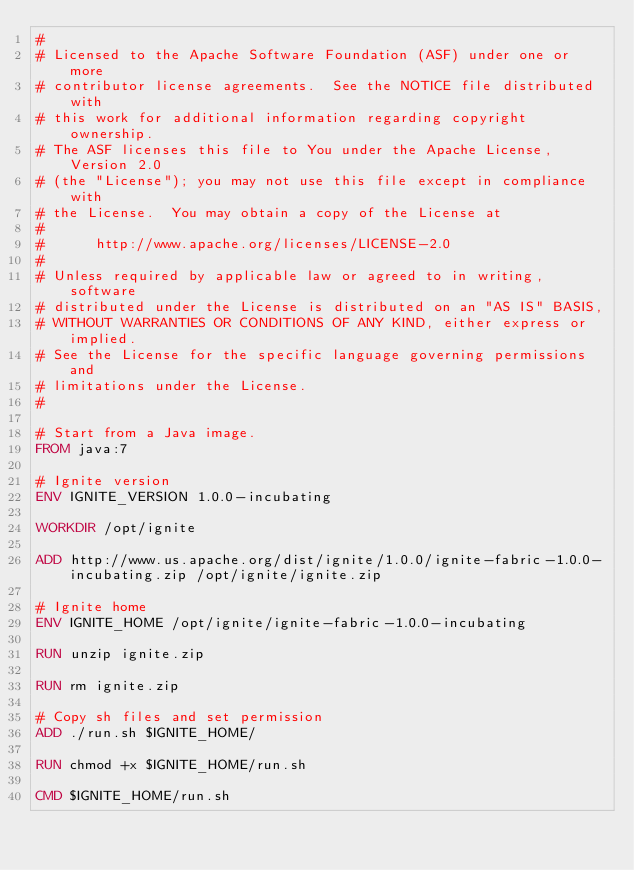<code> <loc_0><loc_0><loc_500><loc_500><_Dockerfile_>#
# Licensed to the Apache Software Foundation (ASF) under one or more
# contributor license agreements.  See the NOTICE file distributed with
# this work for additional information regarding copyright ownership.
# The ASF licenses this file to You under the Apache License, Version 2.0
# (the "License"); you may not use this file except in compliance with
# the License.  You may obtain a copy of the License at
#
#      http://www.apache.org/licenses/LICENSE-2.0
#
# Unless required by applicable law or agreed to in writing, software
# distributed under the License is distributed on an "AS IS" BASIS,
# WITHOUT WARRANTIES OR CONDITIONS OF ANY KIND, either express or implied.
# See the License for the specific language governing permissions and
# limitations under the License.
#

# Start from a Java image.
FROM java:7

# Ignite version
ENV IGNITE_VERSION 1.0.0-incubating

WORKDIR /opt/ignite

ADD http://www.us.apache.org/dist/ignite/1.0.0/ignite-fabric-1.0.0-incubating.zip /opt/ignite/ignite.zip

# Ignite home
ENV IGNITE_HOME /opt/ignite/ignite-fabric-1.0.0-incubating

RUN unzip ignite.zip

RUN rm ignite.zip

# Copy sh files and set permission
ADD ./run.sh $IGNITE_HOME/

RUN chmod +x $IGNITE_HOME/run.sh

CMD $IGNITE_HOME/run.sh</code> 